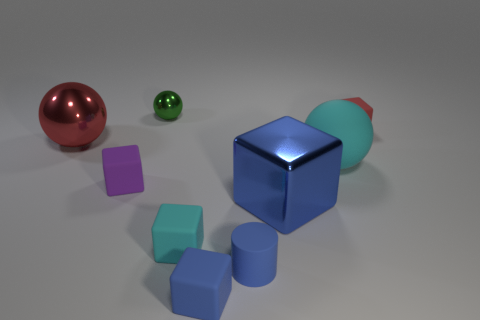Subtract all cyan spheres. How many spheres are left? 2 Subtract all brown balls. How many blue cubes are left? 2 Subtract all blue cubes. How many cubes are left? 3 Subtract 1 spheres. How many spheres are left? 2 Add 1 blue metal things. How many objects exist? 10 Subtract all brown cubes. Subtract all red balls. How many cubes are left? 5 Add 5 big cubes. How many big cubes exist? 6 Subtract 2 blue blocks. How many objects are left? 7 Subtract all balls. How many objects are left? 6 Subtract all red shiny spheres. Subtract all red spheres. How many objects are left? 7 